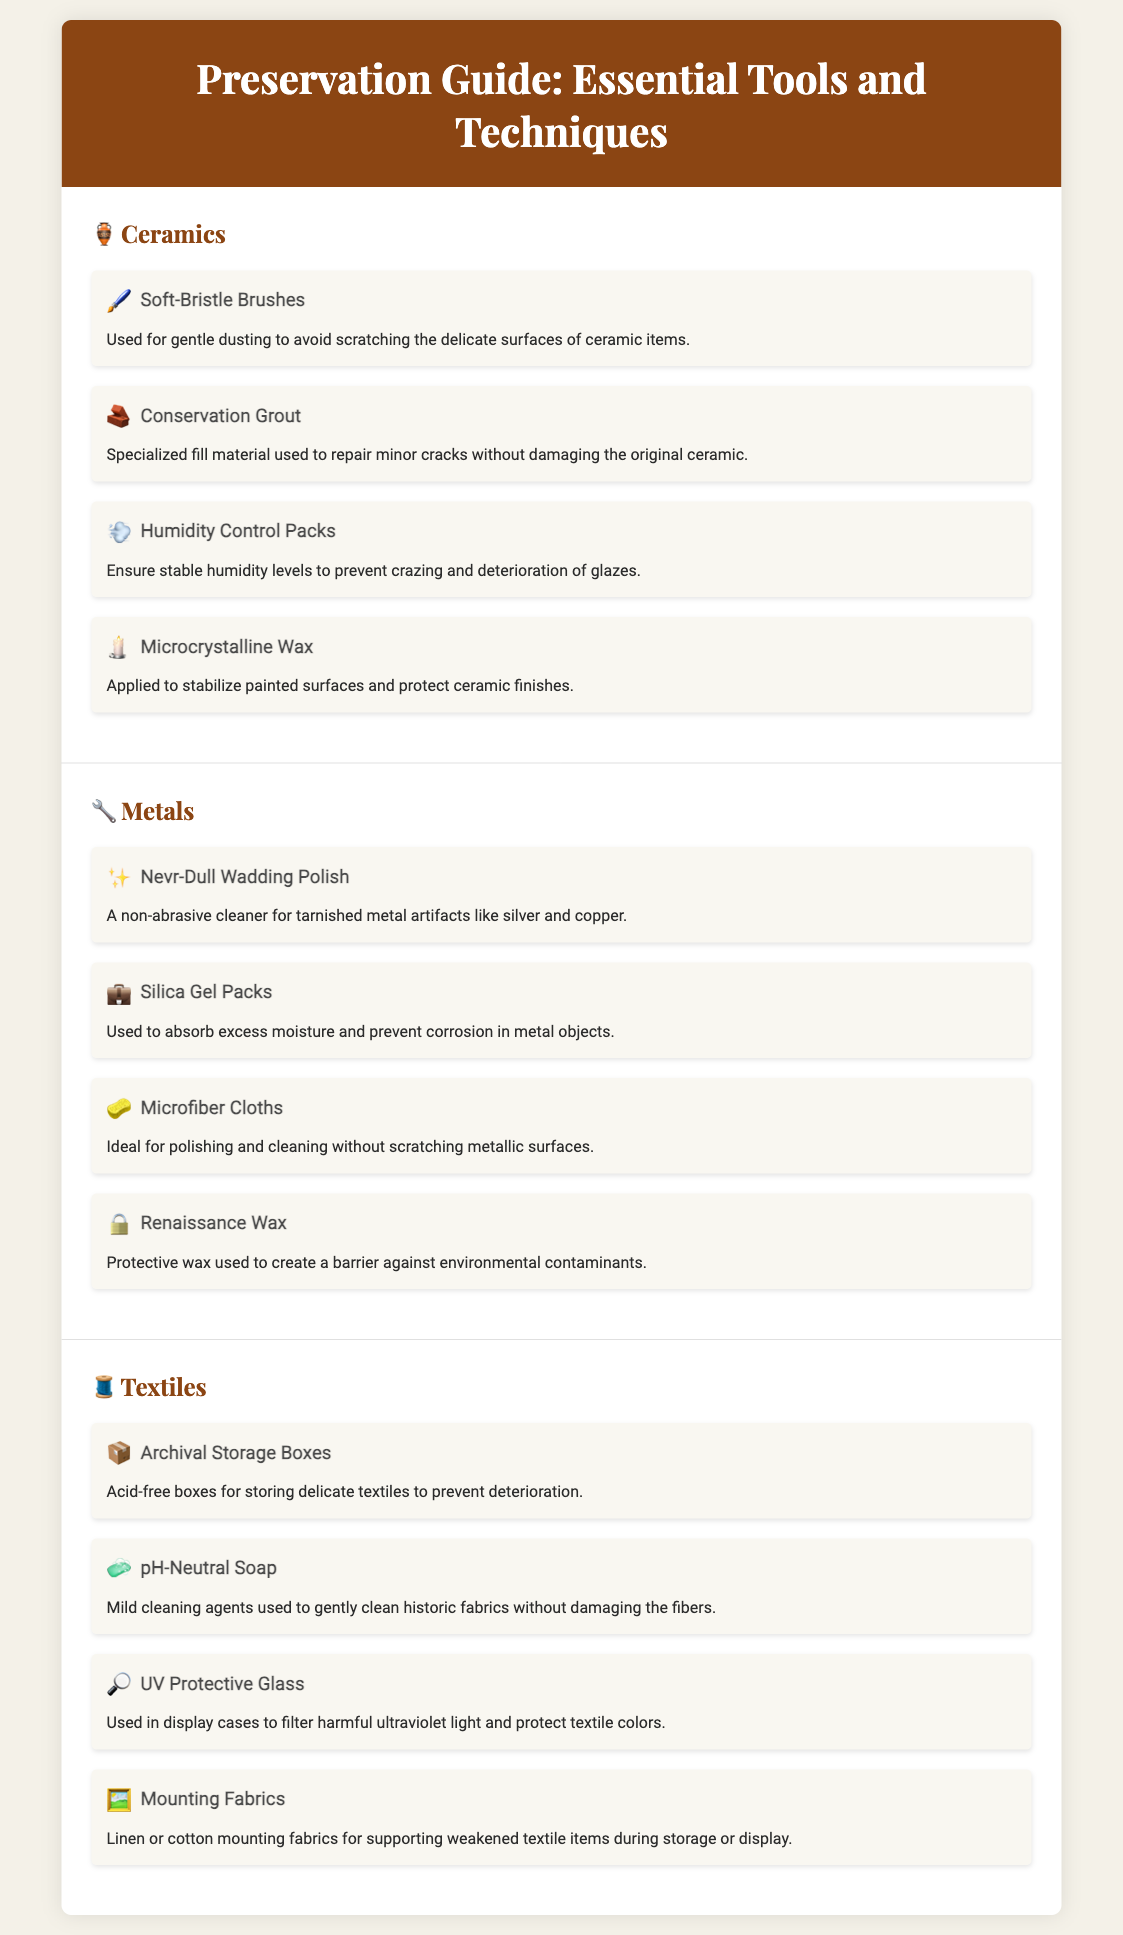What tools are used for gentle dusting of ceramics? The document states that soft-bristle brushes are used for gentle dusting to avoid scratching the delicate surfaces of ceramic items.
Answer: Soft-Bristle Brushes What is the purpose of conservation grout? The document explains that conservation grout is a specialized fill material used to repair minor cracks without damaging the original ceramic.
Answer: Repair minor cracks Which category includes silica gel packs? The document lists silica gel packs under the metals category as they are used to absorb excess moisture and prevent corrosion.
Answer: Metals How many preservation tools are listed for textiles? The document lists four preservation tools specifically for textiles, detailed under the textiles category.
Answer: Four What is the main function of UV protective glass? The document describes the main function of UV protective glass as filtering harmful ultraviolet light to protect textile colors.
Answer: Filter harmful ultraviolet light What type of storage is recommended for delicate textiles? The document recommends archival storage boxes, which are acid-free, for storing delicate textiles.
Answer: Archival Storage Boxes Which wax is mentioned as a protective barrier for metals? The document mentions Renaissance Wax as the protective wax used to create a barrier against environmental contaminants.
Answer: Renaissance Wax What cleaning agent is recommended for historic fabrics? The document suggests using pH-neutral soap as a mild cleaning agent for gently cleaning historic fabrics.
Answer: pH-Neutral Soap 